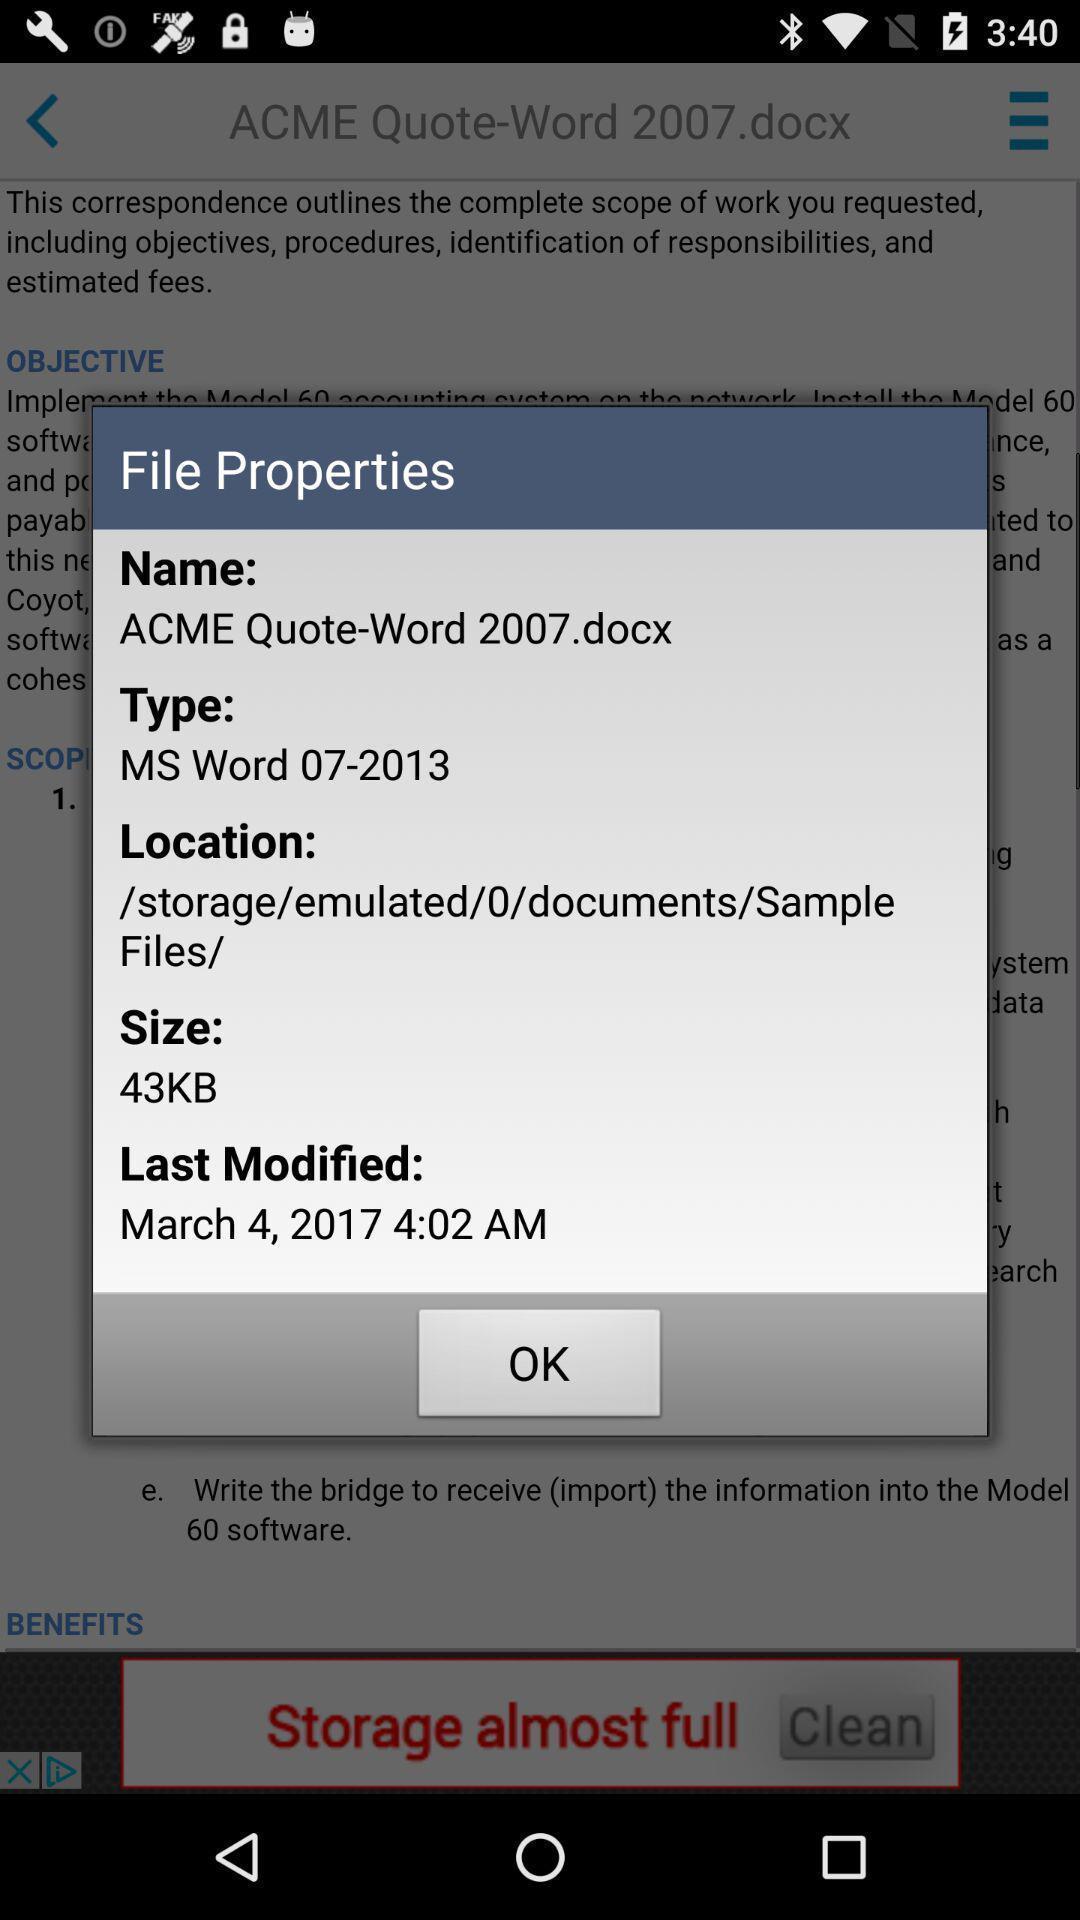Summarize the information in this screenshot. Push up displaying details about document. 